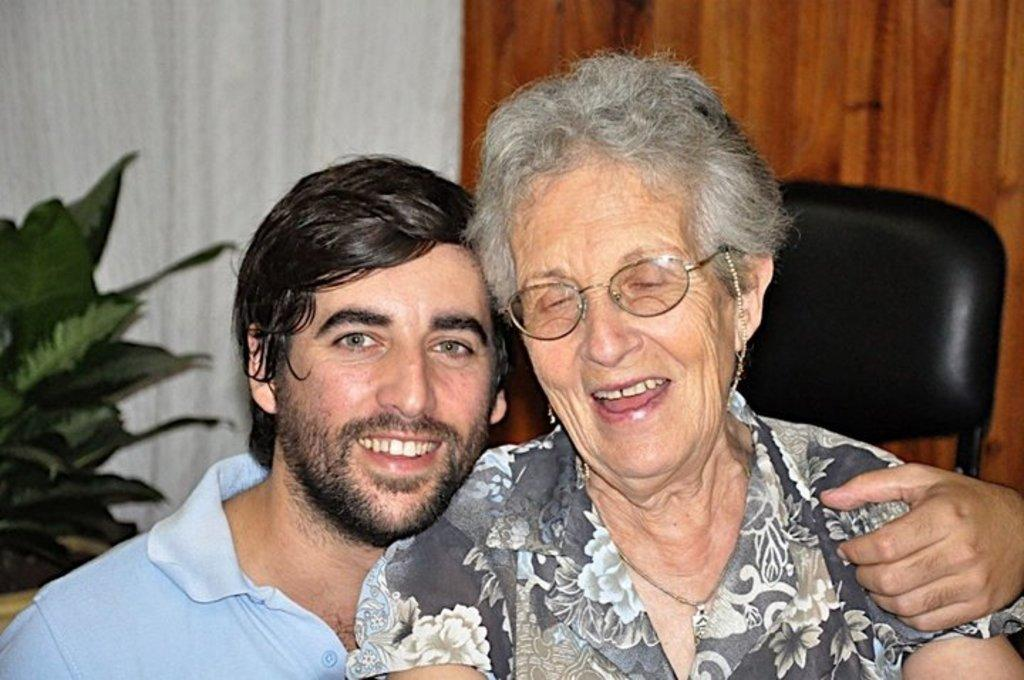How many people are in the image? There are two people in the image, a man and a lady. What are the people in the image wearing? The man is wearing specs, and the lady is wearing specs, earrings, and a chain. What can be seen in the background of the image? There is a chair, a wall, and a plant in the background of the image. What type of goose is sitting on the furniture in the image? There is no goose or furniture present in the image. What hobbies do the people in the image have? The provided facts do not mention any hobbies of the people in the image. 